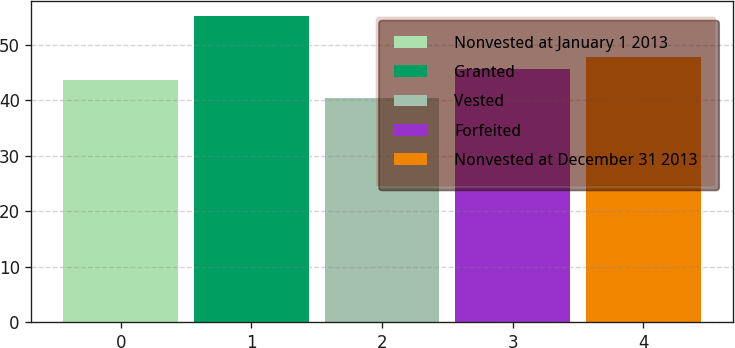Convert chart to OTSL. <chart><loc_0><loc_0><loc_500><loc_500><bar_chart><fcel>Nonvested at January 1 2013<fcel>Granted<fcel>Vested<fcel>Forfeited<fcel>Nonvested at December 31 2013<nl><fcel>43.58<fcel>55.21<fcel>40.33<fcel>45.7<fcel>47.74<nl></chart> 